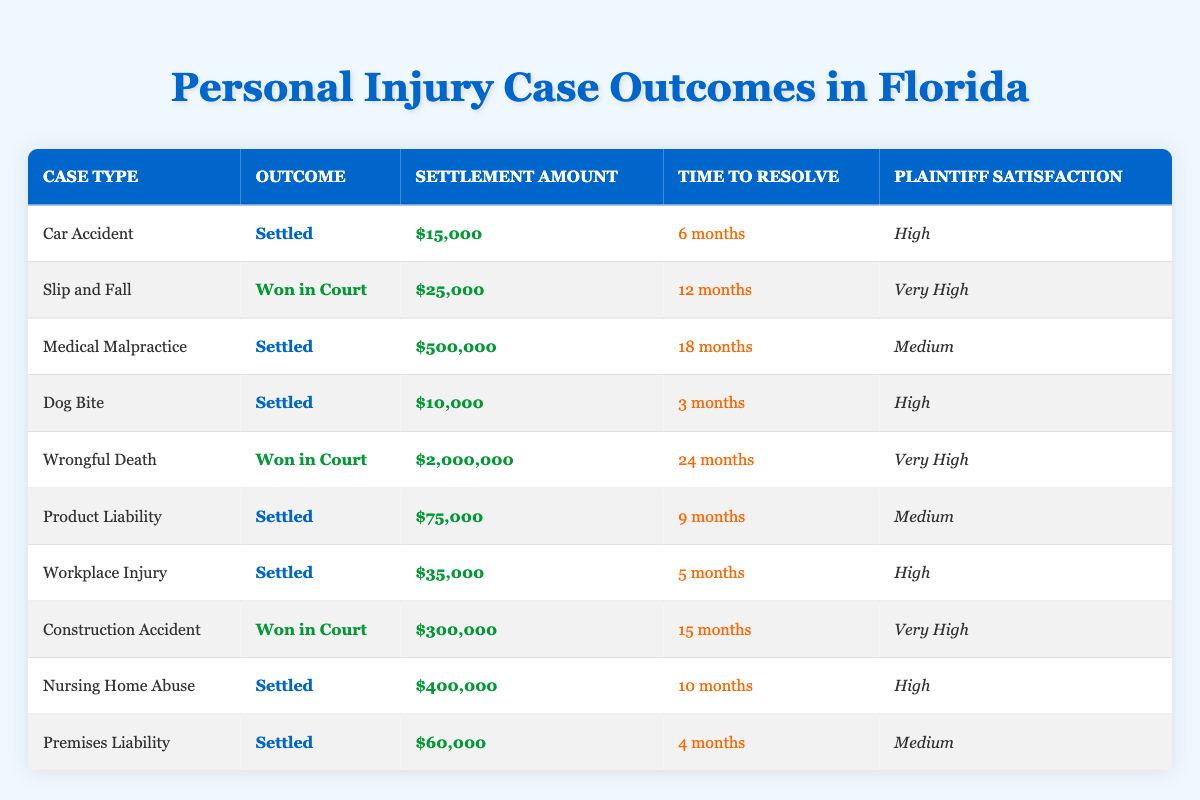What is the outcome for the "Medical Malpractice" case? The outcome for the "Medical Malpractice" case can be found by looking at the corresponding row in the table. The entry states that the outcome is "Settled."
Answer: Settled How much was the settlement amount for "Wrongful Death"? The settlement amount for "Wrongful Death" can be retrieved directly from the table, which shows a settlement of $2,000,000.
Answer: $2,000,000 Which case type took the longest time to resolve? To determine which case took the longest time to resolve, we can compare the "Time to Resolve" for all cases. The "Wrongful Death" case has the longest time listed, which is 24 months.
Answer: Wrongful Death What is the average settlement amount for cases that were settled? First, identify all settled cases and their amounts: $15,000 (Car Accident), $500,000 (Medical Malpractice), $10,000 (Dog Bite), $75,000 (Product Liability), $35,000 (Workplace Injury), $400,000 (Nursing Home Abuse), and $60,000 (Premises Liability). Adding these gives $1,095,000. There are 7 settled cases, so the average is $1,095,000 divided by 7, which equals approximately $156,428.57.
Answer: $156,428.57 Are plaintiffs generally very satisfied with outcomes in "Slip and Fall" and "Construction Accident" cases? The table indicates that the plaintiff satisfaction for "Slip and Fall" is "Very High," and for "Construction Accident," it is also "Very High." This confirms that plaintiffs are generally very satisfied with both outcomes.
Answer: Yes Which case has the highest plaintiff satisfaction rating, and how does that compare to the lowest rating? Looking at the table, the highest rating is "Very High" for both "Slip and Fall" and "Wrongful Death." The lowest is "Medium," seen in "Medical Malpractice," "Product Liability," and "Premises Liability." Thus, the highest and lowest ratings differ by one level.
Answer: Very High; Medium What is the total settlement amount for all cases that were settled? Summing the settlement amounts for all settled cases: $15,000 (Car Accident) + $500,000 (Medical Malpractice) + $10,000 (Dog Bite) + $75,000 (Product Liability) + $35,000 (Workplace Injury) + $400,000 (Nursing Home Abuse) + $60,000 (Premises Liability) equals $1,095,000.
Answer: $1,095,000 Is it true that no case took less than 3 months to resolve? To validate this, we can check the "Time to Resolve" column for all cases. The shortest duration listed is 3 months for the "Dog Bite" case; therefore, it is false that no case took less than 3 months.
Answer: No What percentage of cases resulted in "Won in Court"? There are 2 cases out of a total of 10 that resulted in "Won in Court," which gives a percentage calculated as (2/10) * 100 = 20%.
Answer: 20% 